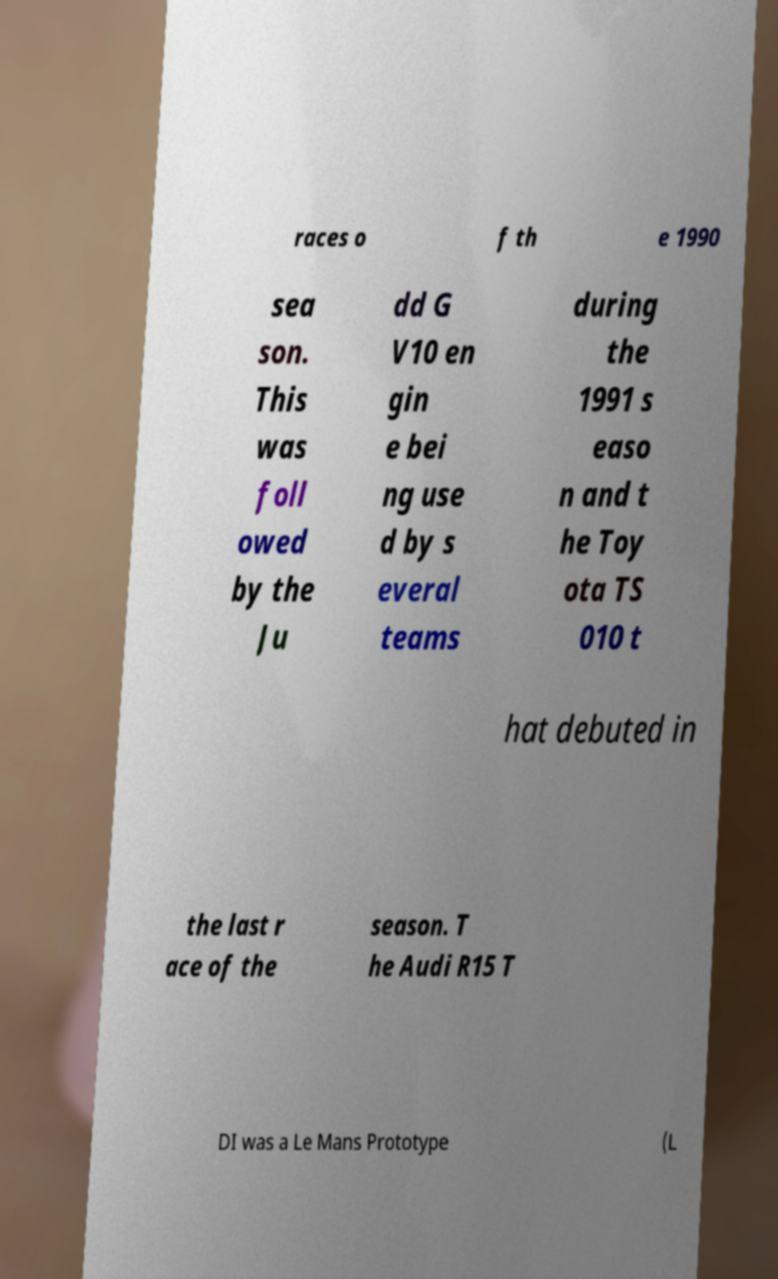There's text embedded in this image that I need extracted. Can you transcribe it verbatim? races o f th e 1990 sea son. This was foll owed by the Ju dd G V10 en gin e bei ng use d by s everal teams during the 1991 s easo n and t he Toy ota TS 010 t hat debuted in the last r ace of the season. T he Audi R15 T DI was a Le Mans Prototype (L 